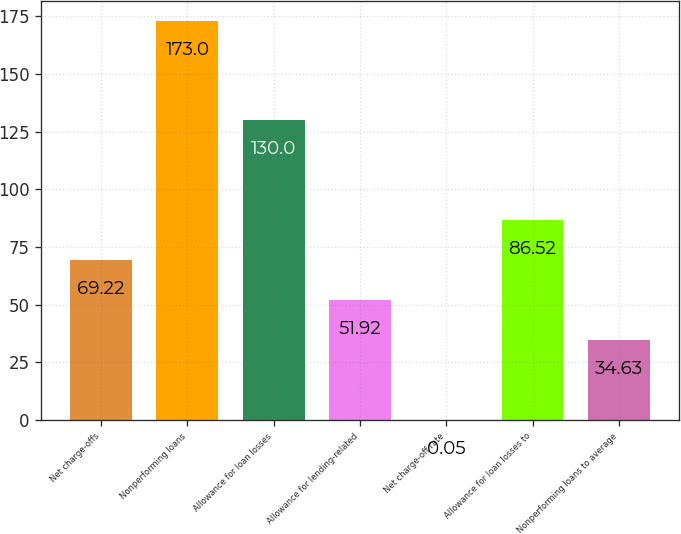<chart> <loc_0><loc_0><loc_500><loc_500><bar_chart><fcel>Net charge-offs<fcel>Nonperforming loans<fcel>Allowance for loan losses<fcel>Allowance for lending-related<fcel>Net charge-off rate<fcel>Allowance for loan losses to<fcel>Nonperforming loans to average<nl><fcel>69.22<fcel>173<fcel>130<fcel>51.92<fcel>0.05<fcel>86.52<fcel>34.63<nl></chart> 